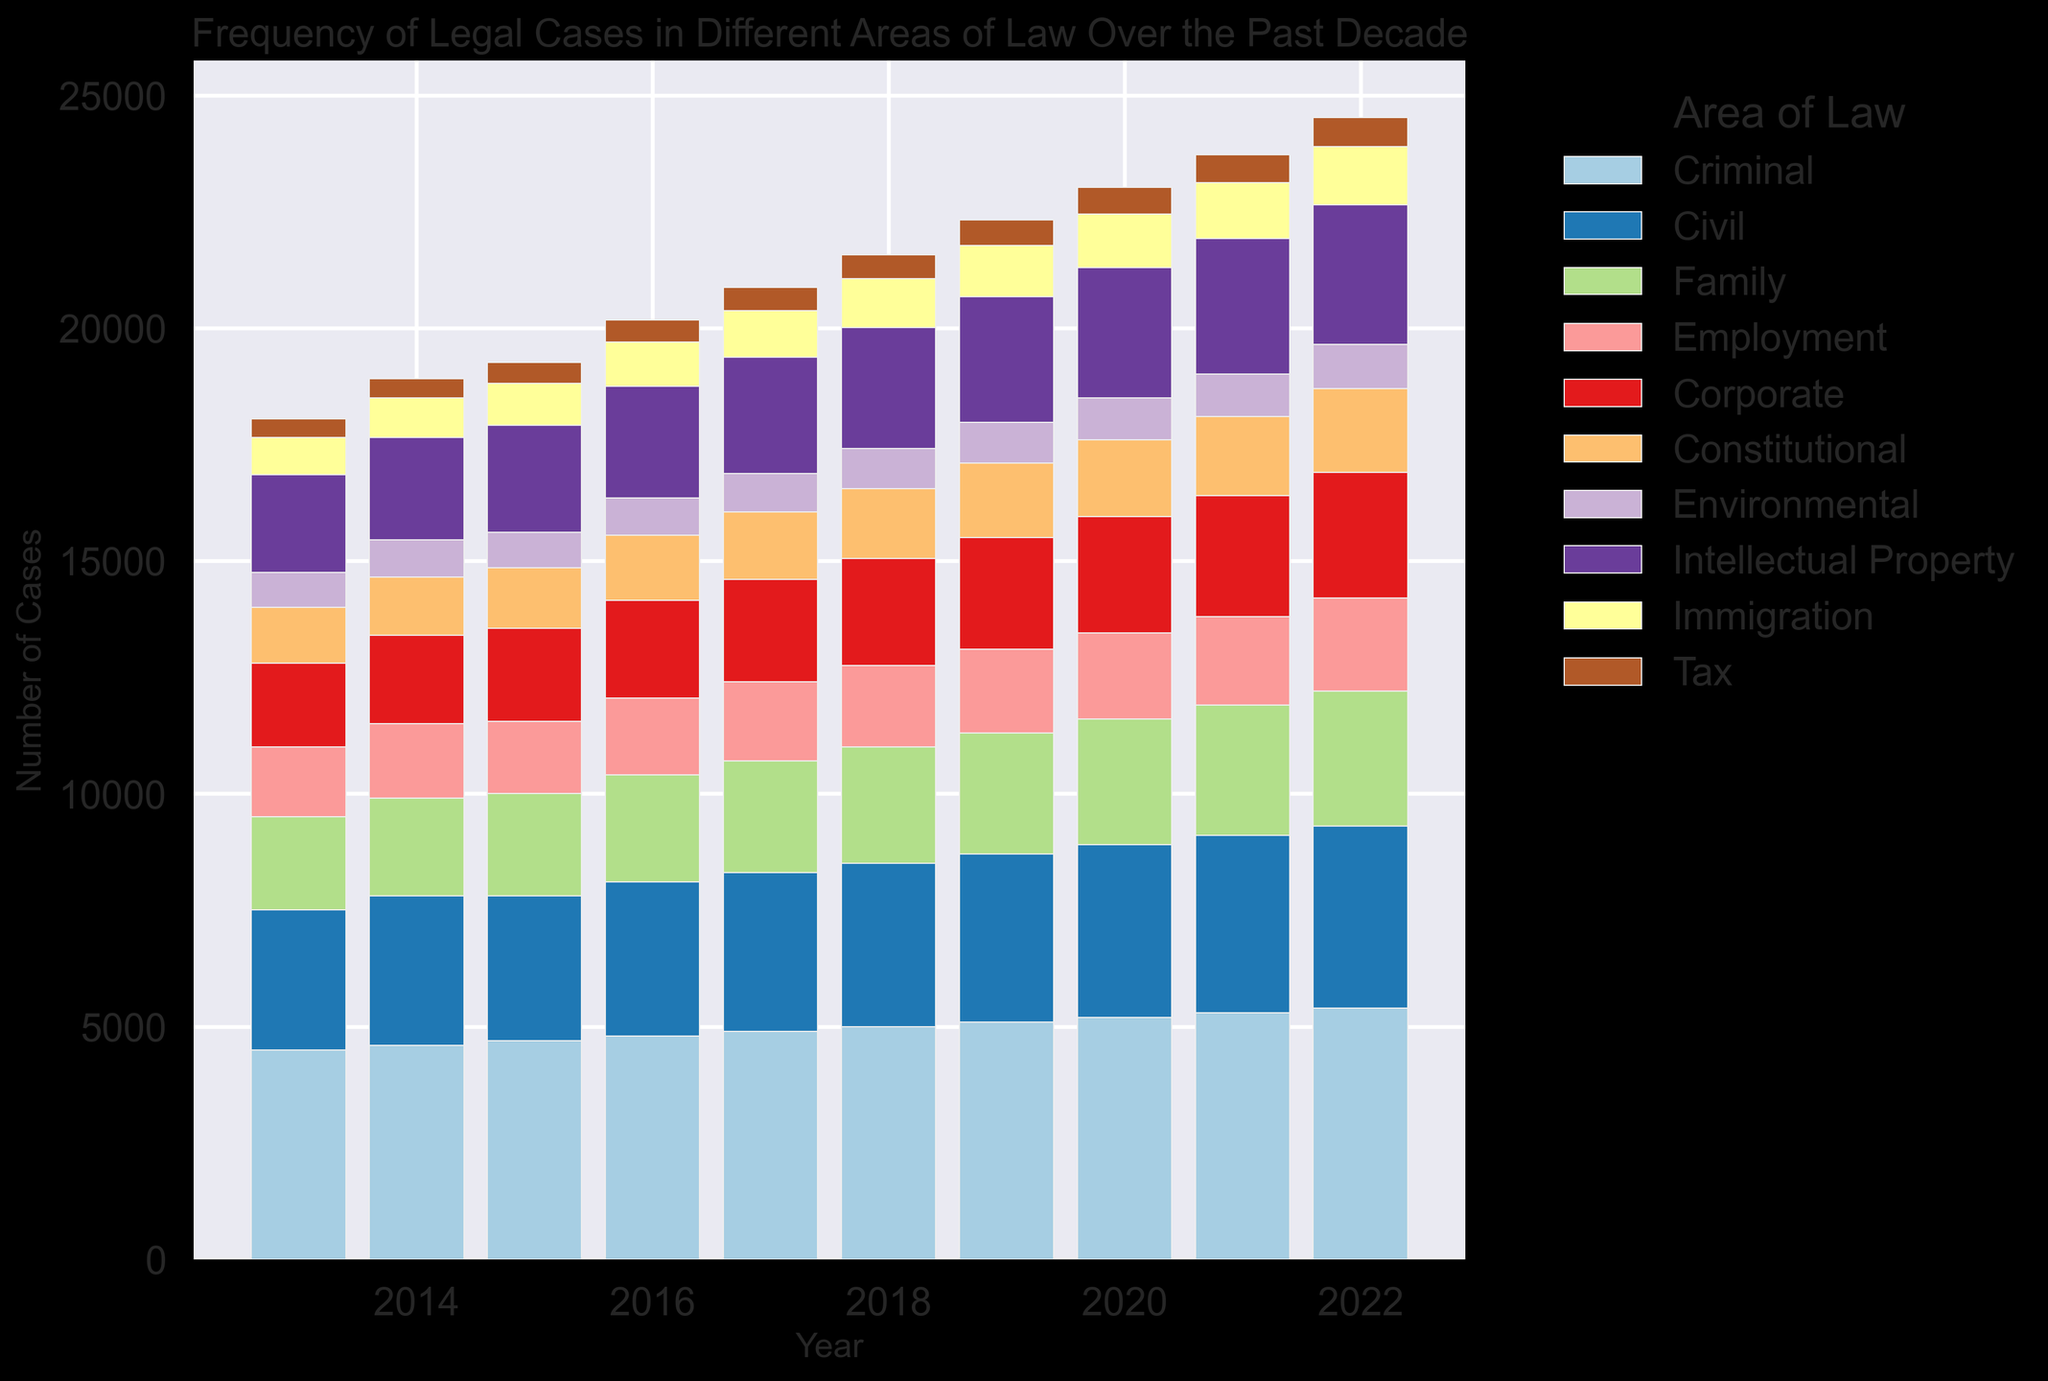What's the total number of criminal and civil cases in 2017? Sum the values for criminal and civil cases in 2017. Criminal: 4900, Civil: 3400, Total = 4900 + 3400 = 8300
Answer: 8300 Which area of law saw the greatest increase in cases from 2013 to 2022? Calculate the increase for each category by subtracting the values of 2013 from 2022 and identify the highest increase. Criminal: 5400-4500=900, Civil: 3900-3000=900, Family: 2900-2000=900, Employment: 2000-1500=500, Corporate: 2700-1800=900, Constitutional: 1800-1200=600, Environmental: 950-750=200, Intellectual Property: 3000-2100=900, Immigration: 1250-800=450, Tax: 620-400=220; Criminal, Civil, Family, Corporate, and Intellectual Property each saw an increase of 900
Answer: Criminal, Civil, Family, Corporate, Intellectual Property In which year did employment law cases first reach 2000? Track the values for employment law from 2013 to 2022 and find the first year it reached 2000. For Employment: increases from 1500 to 2000 in 2022
Answer: 2022 What is the average number of environmental law cases over the decade? Sum up the values for environmental law cases from 2013 to 2022 and divide by the number of years (10). Total = 750+800+770+800+830+860+880+900+920+950 = 8360; Average = 8360/10
Answer: 836 Comparing the number of immigration law cases with tax law cases in 2020, which is higher? For 2020, Immigration: 1150, Tax: 580. Immigration cases are higher than tax cases
Answer: Immigration What's the difference in the number of criminal cases between 2015 and 2022? Values for Criminal cases in 2015 and 2022: 4700 and 5400 respectively. Difference = 5400 - 4700
Answer: 700 Which year had the lowest total number of cases across all categories? Calculate the total cases for each year and identify the lowest. 2013: 15550, 2014: 16620, 2015: 16970, 2016: 17650, 2017: 18330, 2018: 19080, 2019: 19780, 2020: 20480, 2021: 21220, 2022: 22020. 2013 had the lowest total number of cases.
Answer: 2013 Which area of law increased steadily over the entire decade without any decrease? Track the values for each area from 2013 to 2022 to find any area with a steady increase each year. Criminal, Employment, Corporate, Immigration, Tax
Answer: Criminal, Employment, Corporate, Immigration, Tax What is the combined average number of family and employment law cases in 2021? Sum the values for family and employment law cases in 2021 and divide by 2. Family: 2800, Employment: 1900. Combined Average = (2800+1900)/2
Answer: 2350 